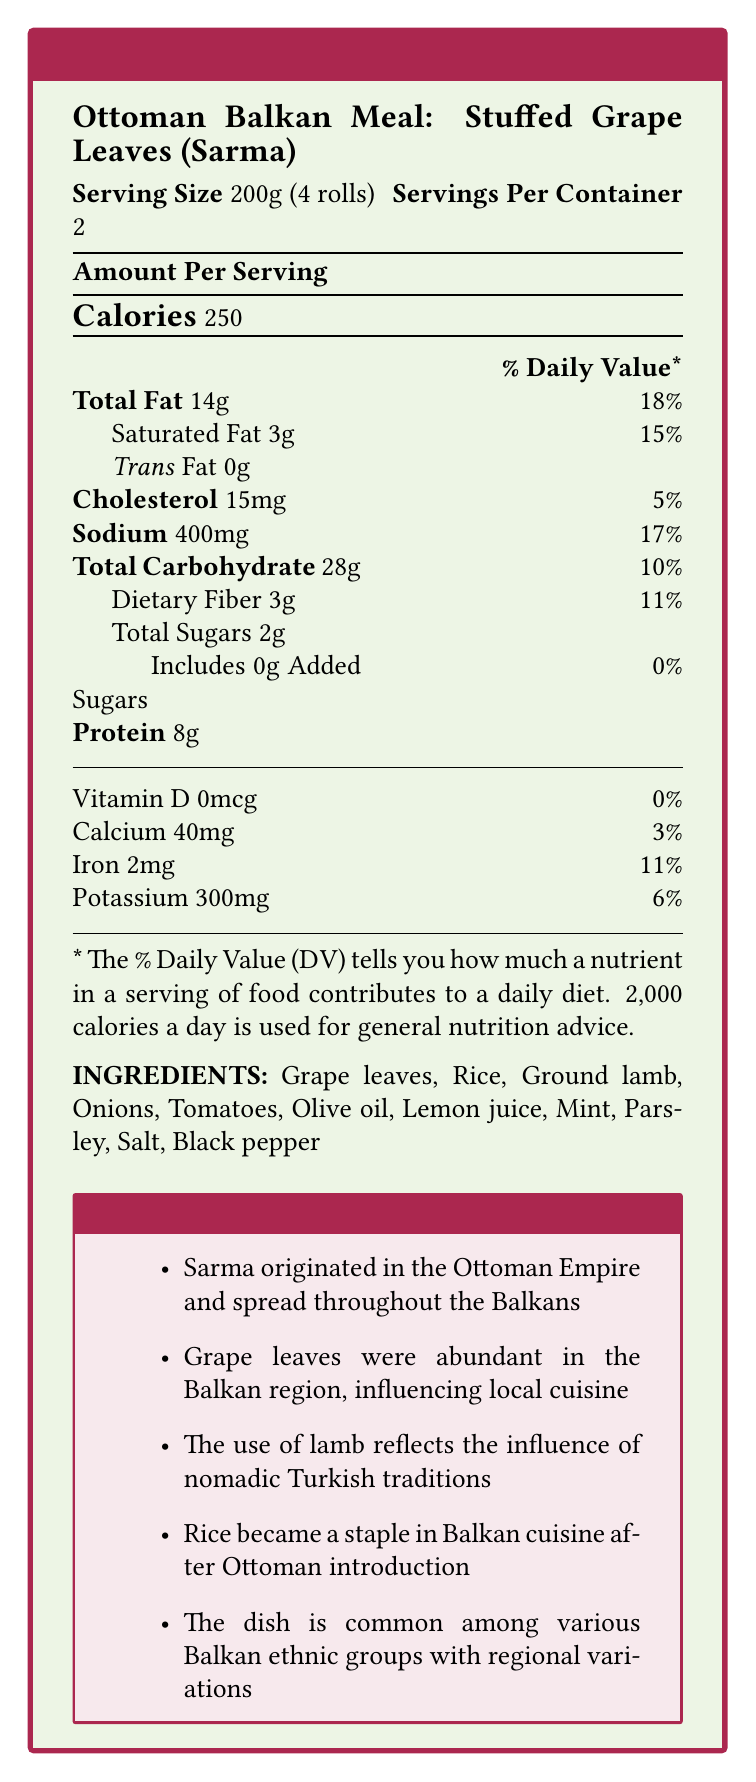what is the serving size of the Ottoman Balkan Meal: Stuffed Grape Leaves (Sarma)? The serving size is explicitly mentioned on the label as 200g (4 rolls).
Answer: 200g (4 rolls) how many calories are there per serving? The document states the calories per serving as 250.
Answer: 250 what is the total amount of fat per serving and its percentage of daily value? The document clearly indicates that total fat per serving is 14g which is 18% of the daily value.
Answer: 14g, 18% what ingredients are used in this dish? The ingredients are listed under the “INGREDIENTS” section of the document.
Answer: Grape leaves, Rice, Ground lamb, Onions, Tomatoes, Olive oil, Lemon juice, Mint, Parsley, Salt, Black pepper what is the source of the potassium in this meal? The document only lists the amount of potassium, not its specific sources.
Answer: Cannot be determined what percentage of the daily value of dietary fiber does this meal provide per serving? The dietary fiber per serving is listed as 3g and it contributes to 11% of the daily value.
Answer: 11% how many servings are there per container? According to the label, there are 2 servings per container.
Answer: 2 the use of what ingredient reflects the influence of nomadic Turkish traditions? A. Grape leaves B. Rice C. Ground lamb D. Olive oil The document's cultural annotations state that the use of ground lamb reflects the influence of nomadic Turkish traditions.
Answer: C which nutrient does this meal have zero percent daily value for? A. Vitamin D B. Calcium C. Iron D. Potassium The label shows that Vitamin D has a 0% daily value.
Answer: A does this meal contain any trans fat? The document states there is 0g of trans fat.
Answer: No what are the cultural significances of this meal? The cultural annotations highlight these points: 1) Sarma's origin and spread during Ottoman rule indicating cultural diffusion; 2) Adaptation to local resources through the use of grape leaves; 3) The influence of Turkish nomadic traditions reflected in the use of lamb; 4) Long-term impact of Ottoman rule demonstrated by rice becoming a staple; 5) Shared culinary heritage among various Balkan ethnic groups with regional variations.
Answer: Sarma originated in the Ottoman Empire and spread throughout the Balkans; Grape leaves were abundant in the Balkan region influencing local cuisine; The use of lamb reflects the influence of nomadic Turkish traditions; Rice became a staple in Balkan cuisine after Ottoman introduction; The dish is common among various Balkan ethnic groups with regional variations. how much protein is in one serving? The document lists protein content as 8g per serving.
Answer: 8g what was the influence of Ottoman rule on the use of rice in Balkan cuisine? The cultural annotations note that rice's introduction by the Ottomans led to its integration as a staple in local diets.
Answer: Rice became a staple in Balkan cuisine after the Ottoman introduction, indicating a long-term impact. 